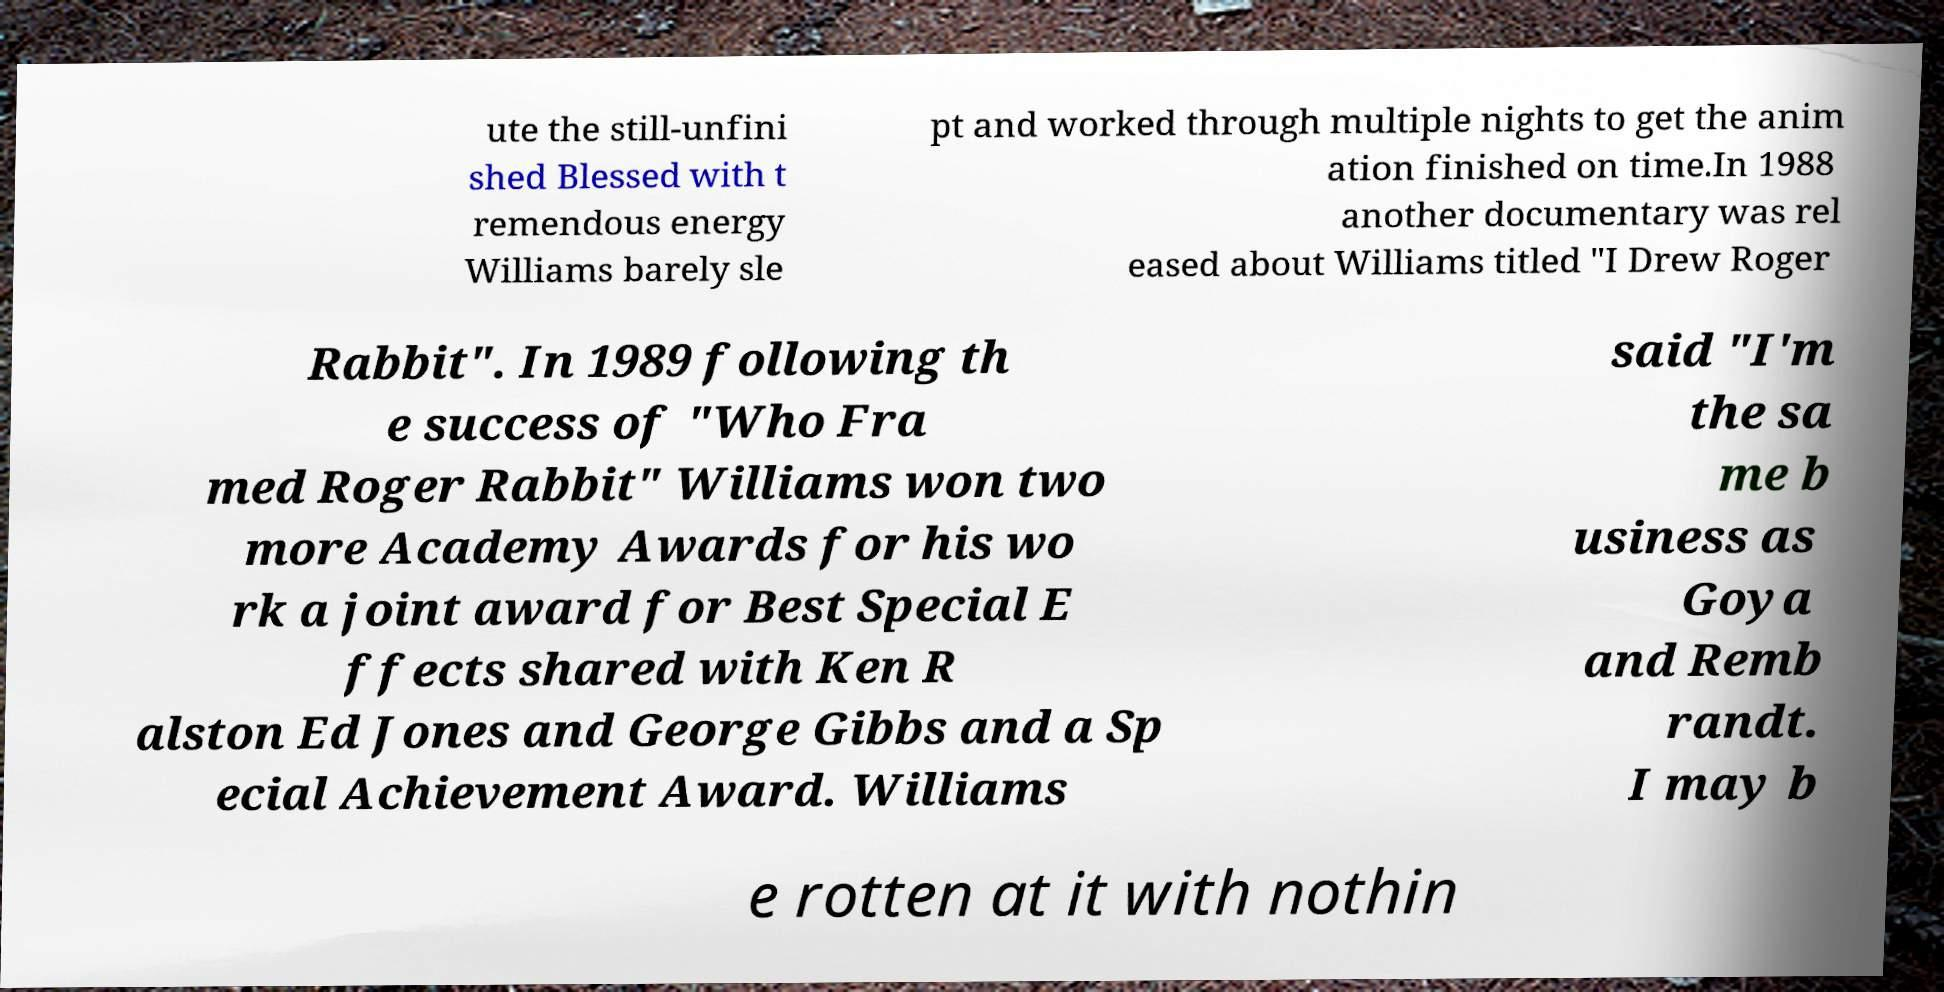There's text embedded in this image that I need extracted. Can you transcribe it verbatim? ute the still-unfini shed Blessed with t remendous energy Williams barely sle pt and worked through multiple nights to get the anim ation finished on time.In 1988 another documentary was rel eased about Williams titled "I Drew Roger Rabbit". In 1989 following th e success of "Who Fra med Roger Rabbit" Williams won two more Academy Awards for his wo rk a joint award for Best Special E ffects shared with Ken R alston Ed Jones and George Gibbs and a Sp ecial Achievement Award. Williams said "I'm the sa me b usiness as Goya and Remb randt. I may b e rotten at it with nothin 